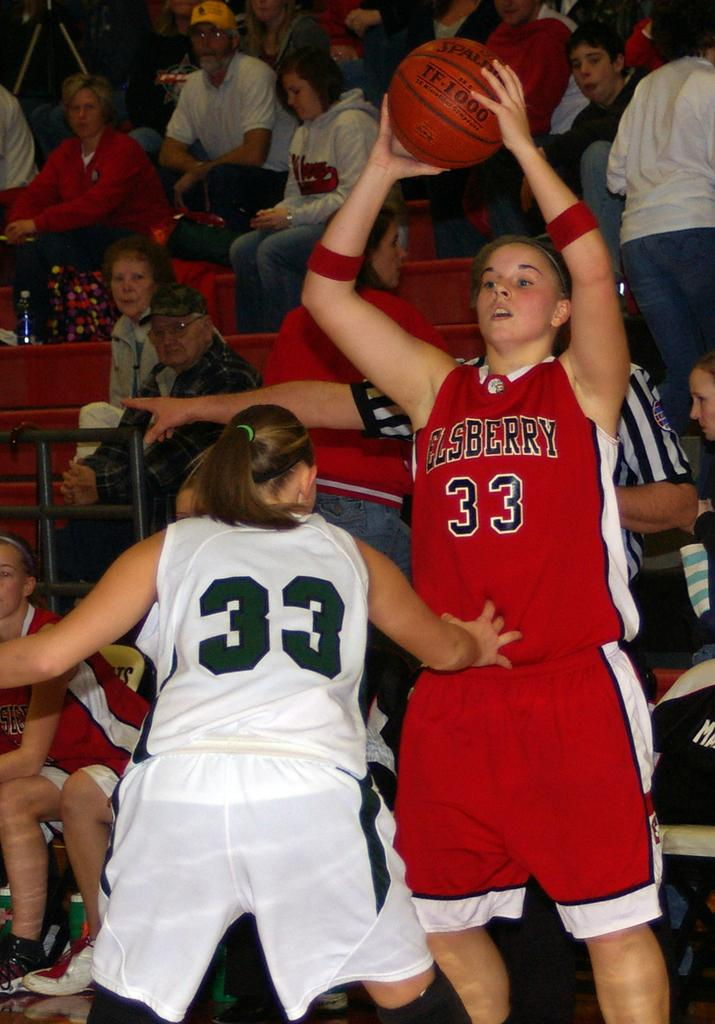<image>
Write a terse but informative summary of the picture. Two girls basketball players both have the number 33 one in red and one in white 